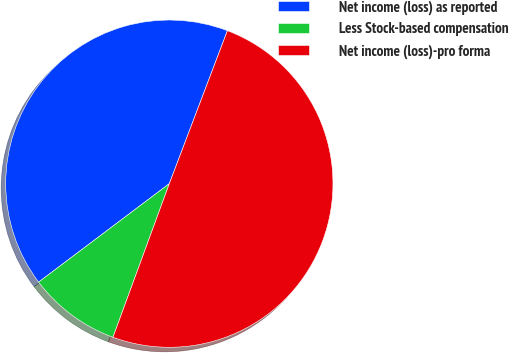Convert chart to OTSL. <chart><loc_0><loc_0><loc_500><loc_500><pie_chart><fcel>Net income (loss) as reported<fcel>Less Stock-based compensation<fcel>Net income (loss)-pro forma<nl><fcel>41.05%<fcel>9.13%<fcel>49.82%<nl></chart> 